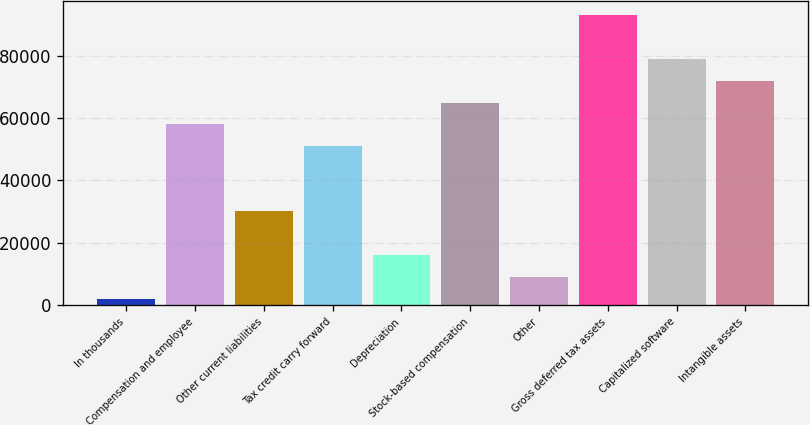Convert chart to OTSL. <chart><loc_0><loc_0><loc_500><loc_500><bar_chart><fcel>In thousands<fcel>Compensation and employee<fcel>Other current liabilities<fcel>Tax credit carry forward<fcel>Depreciation<fcel>Stock-based compensation<fcel>Other<fcel>Gross deferred tax assets<fcel>Capitalized software<fcel>Intangible assets<nl><fcel>2008<fcel>57996.8<fcel>30002.4<fcel>50998.2<fcel>16005.2<fcel>64995.4<fcel>9006.6<fcel>92989.8<fcel>78992.6<fcel>71994<nl></chart> 